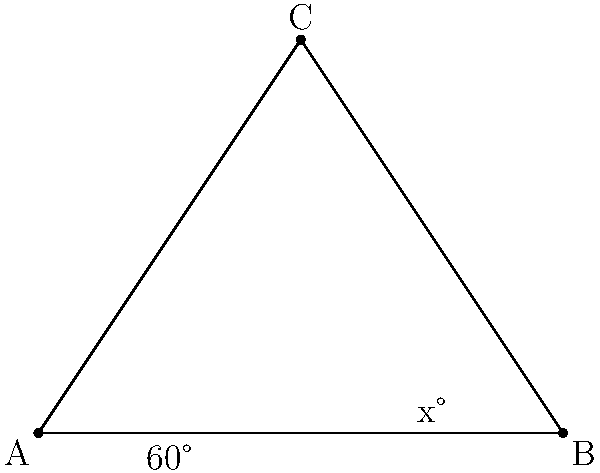In your latest avant-garde fashion design, you've incorporated a triangular cutout with unconventional angles. If one of the angles in this triangle is 60°, and another is twice the measure of the third angle, what is the measure of the largest angle in the triangle? Let's approach this step-by-step:

1) First, recall that the sum of angles in a triangle is always 180°.

2) Let's denote the unknown angle as $x°$. We know one angle is 60°, and another is $2x°$ (twice the measure of $x°$).

3) We can set up an equation based on the fact that these angles must sum to 180°:

   $60° + x° + 2x° = 180°$

4) Simplify the left side of the equation:

   $60° + 3x° = 180°$

5) Subtract 60° from both sides:

   $3x° = 120°$

6) Divide both sides by 3:

   $x° = 40°$

7) Now we know all three angles: 60°, 40°, and 80° (which is $2x°$ or $2 * 40°$)

8) The largest angle is 80°.
Answer: 80° 